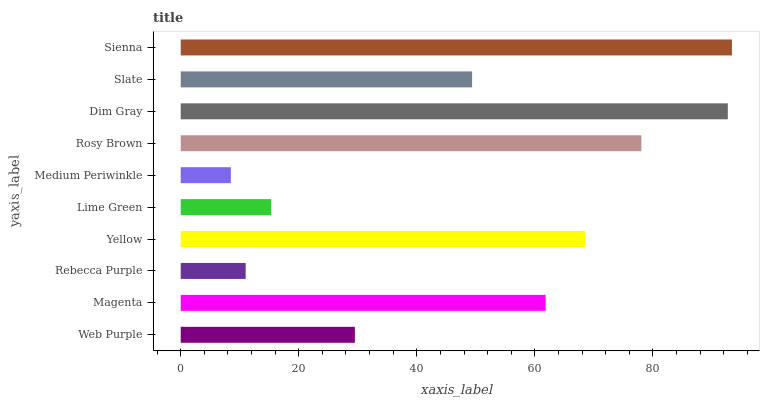Is Medium Periwinkle the minimum?
Answer yes or no. Yes. Is Sienna the maximum?
Answer yes or no. Yes. Is Magenta the minimum?
Answer yes or no. No. Is Magenta the maximum?
Answer yes or no. No. Is Magenta greater than Web Purple?
Answer yes or no. Yes. Is Web Purple less than Magenta?
Answer yes or no. Yes. Is Web Purple greater than Magenta?
Answer yes or no. No. Is Magenta less than Web Purple?
Answer yes or no. No. Is Magenta the high median?
Answer yes or no. Yes. Is Slate the low median?
Answer yes or no. Yes. Is Web Purple the high median?
Answer yes or no. No. Is Magenta the low median?
Answer yes or no. No. 